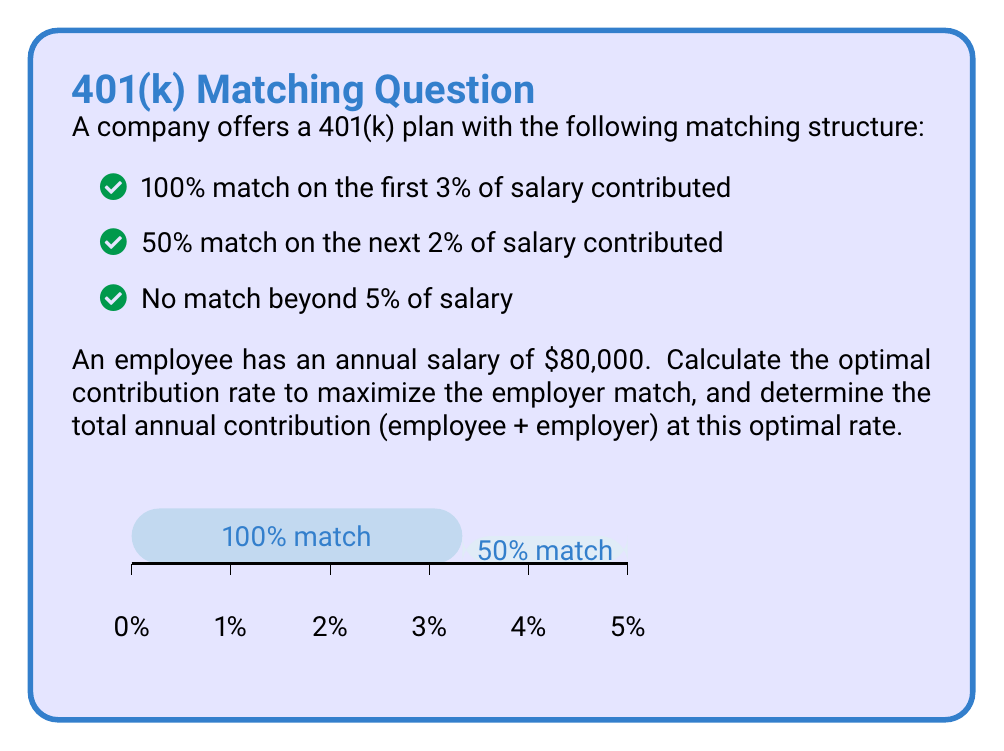Can you solve this math problem? Let's approach this step-by-step:

1) First, we need to understand the matching structure:
   - The first 3% of salary gets a 100% match
   - The next 2% gets a 50% match
   - Anything beyond 5% gets no match

2) To maximize the employer match, we should contribute at least 5% of the salary. Let's calculate this:

   5% of $80,000 = $80,000 * 0.05 = $4,000

3) Now, let's calculate the employer match:
   - For the first 3%: 100% of (3% * $80,000) = $2,400
   - For the next 2%: 50% of (2% * $80,000) = $800
   
   Total employer match = $2,400 + $800 = $3,200

4) The optimal contribution rate is 5%, as contributing more won't increase the employer match.

5) To calculate the total annual contribution:
   Employee contribution: $4,000
   Employer match: $3,200
   
   Total = $4,000 + $3,200 = $7,200

6) We can express this as a percentage of the salary:
   $7,200 / $80,000 = 0.09 = 9%

Therefore, the optimal strategy is to contribute 5% of the salary, which results in a total contribution (employee + employer) of 9% of the salary.
Answer: 5% employee contribution; 9% total contribution 